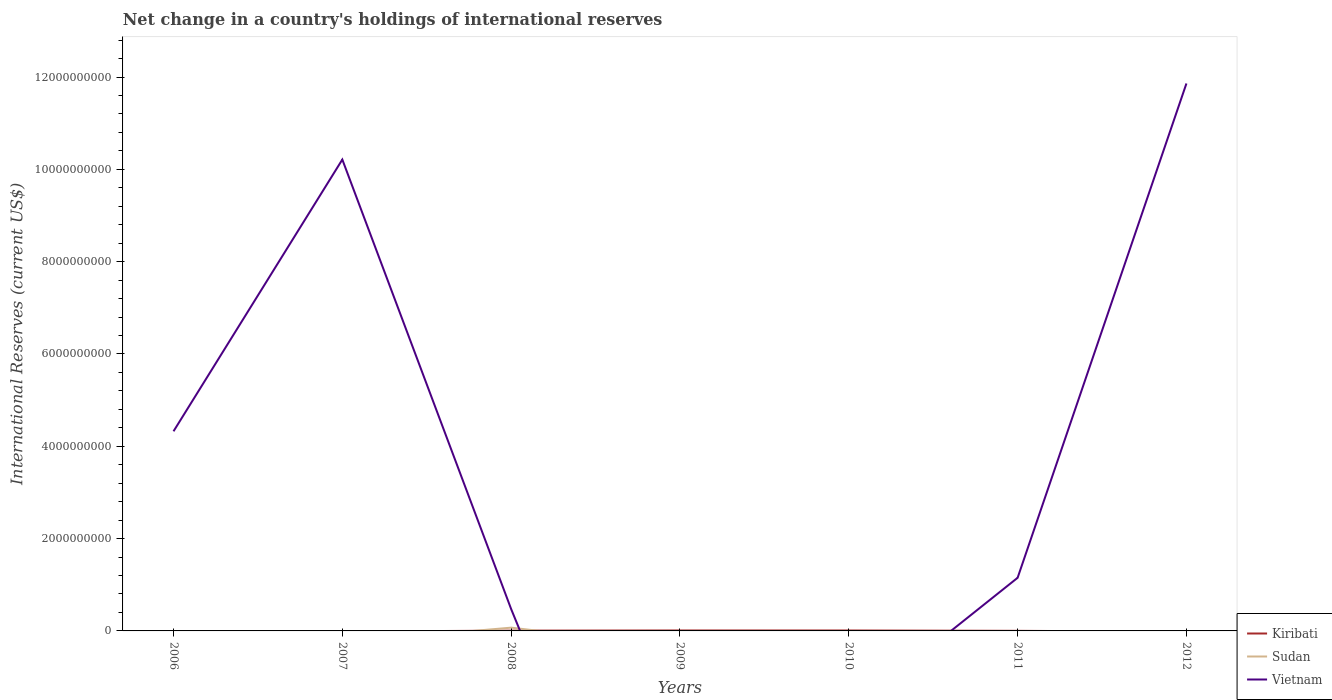Is the number of lines equal to the number of legend labels?
Offer a terse response. No. What is the total international reserves in Kiribati in the graph?
Offer a very short reply. 4.58e+06. What is the difference between the highest and the second highest international reserves in Sudan?
Offer a terse response. 7.08e+07. What is the difference between the highest and the lowest international reserves in Vietnam?
Offer a very short reply. 3. What is the difference between two consecutive major ticks on the Y-axis?
Offer a terse response. 2.00e+09. Are the values on the major ticks of Y-axis written in scientific E-notation?
Ensure brevity in your answer.  No. Does the graph contain any zero values?
Your answer should be very brief. Yes. Does the graph contain grids?
Your response must be concise. No. Where does the legend appear in the graph?
Provide a short and direct response. Bottom right. What is the title of the graph?
Provide a succinct answer. Net change in a country's holdings of international reserves. Does "Montenegro" appear as one of the legend labels in the graph?
Ensure brevity in your answer.  No. What is the label or title of the X-axis?
Your answer should be compact. Years. What is the label or title of the Y-axis?
Your answer should be very brief. International Reserves (current US$). What is the International Reserves (current US$) in Kiribati in 2006?
Ensure brevity in your answer.  0. What is the International Reserves (current US$) in Sudan in 2006?
Your answer should be very brief. 0. What is the International Reserves (current US$) in Vietnam in 2006?
Provide a short and direct response. 4.32e+09. What is the International Reserves (current US$) in Kiribati in 2007?
Provide a succinct answer. 0. What is the International Reserves (current US$) in Sudan in 2007?
Provide a succinct answer. 0. What is the International Reserves (current US$) of Vietnam in 2007?
Your answer should be very brief. 1.02e+1. What is the International Reserves (current US$) in Kiribati in 2008?
Ensure brevity in your answer.  6.53e+06. What is the International Reserves (current US$) of Sudan in 2008?
Offer a very short reply. 7.08e+07. What is the International Reserves (current US$) of Vietnam in 2008?
Offer a very short reply. 4.74e+08. What is the International Reserves (current US$) in Kiribati in 2009?
Your answer should be very brief. 9.89e+06. What is the International Reserves (current US$) in Sudan in 2009?
Offer a very short reply. 0. What is the International Reserves (current US$) in Kiribati in 2010?
Keep it short and to the point. 9.50e+06. What is the International Reserves (current US$) in Sudan in 2010?
Your response must be concise. 0. What is the International Reserves (current US$) in Vietnam in 2010?
Keep it short and to the point. 0. What is the International Reserves (current US$) of Kiribati in 2011?
Offer a terse response. 1.95e+06. What is the International Reserves (current US$) in Sudan in 2011?
Your answer should be compact. 0. What is the International Reserves (current US$) in Vietnam in 2011?
Make the answer very short. 1.15e+09. What is the International Reserves (current US$) of Kiribati in 2012?
Keep it short and to the point. 0. What is the International Reserves (current US$) of Vietnam in 2012?
Make the answer very short. 1.19e+1. Across all years, what is the maximum International Reserves (current US$) in Kiribati?
Provide a succinct answer. 9.89e+06. Across all years, what is the maximum International Reserves (current US$) of Sudan?
Offer a very short reply. 7.08e+07. Across all years, what is the maximum International Reserves (current US$) in Vietnam?
Provide a short and direct response. 1.19e+1. Across all years, what is the minimum International Reserves (current US$) of Sudan?
Ensure brevity in your answer.  0. Across all years, what is the minimum International Reserves (current US$) in Vietnam?
Ensure brevity in your answer.  0. What is the total International Reserves (current US$) of Kiribati in the graph?
Offer a very short reply. 2.79e+07. What is the total International Reserves (current US$) of Sudan in the graph?
Your answer should be compact. 7.08e+07. What is the total International Reserves (current US$) of Vietnam in the graph?
Provide a short and direct response. 2.80e+1. What is the difference between the International Reserves (current US$) in Vietnam in 2006 and that in 2007?
Provide a succinct answer. -5.89e+09. What is the difference between the International Reserves (current US$) in Vietnam in 2006 and that in 2008?
Provide a succinct answer. 3.85e+09. What is the difference between the International Reserves (current US$) of Vietnam in 2006 and that in 2011?
Make the answer very short. 3.17e+09. What is the difference between the International Reserves (current US$) of Vietnam in 2006 and that in 2012?
Ensure brevity in your answer.  -7.54e+09. What is the difference between the International Reserves (current US$) of Vietnam in 2007 and that in 2008?
Offer a very short reply. 9.74e+09. What is the difference between the International Reserves (current US$) in Vietnam in 2007 and that in 2011?
Your response must be concise. 9.06e+09. What is the difference between the International Reserves (current US$) of Vietnam in 2007 and that in 2012?
Offer a terse response. -1.65e+09. What is the difference between the International Reserves (current US$) in Kiribati in 2008 and that in 2009?
Your answer should be compact. -3.36e+06. What is the difference between the International Reserves (current US$) in Kiribati in 2008 and that in 2010?
Make the answer very short. -2.97e+06. What is the difference between the International Reserves (current US$) of Kiribati in 2008 and that in 2011?
Keep it short and to the point. 4.58e+06. What is the difference between the International Reserves (current US$) in Vietnam in 2008 and that in 2011?
Your answer should be very brief. -6.77e+08. What is the difference between the International Reserves (current US$) of Vietnam in 2008 and that in 2012?
Provide a short and direct response. -1.14e+1. What is the difference between the International Reserves (current US$) in Kiribati in 2009 and that in 2010?
Make the answer very short. 3.84e+05. What is the difference between the International Reserves (current US$) of Kiribati in 2009 and that in 2011?
Offer a very short reply. 7.94e+06. What is the difference between the International Reserves (current US$) of Kiribati in 2010 and that in 2011?
Provide a succinct answer. 7.55e+06. What is the difference between the International Reserves (current US$) in Vietnam in 2011 and that in 2012?
Your answer should be compact. -1.07e+1. What is the difference between the International Reserves (current US$) of Kiribati in 2008 and the International Reserves (current US$) of Vietnam in 2011?
Provide a short and direct response. -1.14e+09. What is the difference between the International Reserves (current US$) in Sudan in 2008 and the International Reserves (current US$) in Vietnam in 2011?
Your answer should be compact. -1.08e+09. What is the difference between the International Reserves (current US$) in Kiribati in 2008 and the International Reserves (current US$) in Vietnam in 2012?
Provide a short and direct response. -1.19e+1. What is the difference between the International Reserves (current US$) in Sudan in 2008 and the International Reserves (current US$) in Vietnam in 2012?
Give a very brief answer. -1.18e+1. What is the difference between the International Reserves (current US$) of Kiribati in 2009 and the International Reserves (current US$) of Vietnam in 2011?
Offer a very short reply. -1.14e+09. What is the difference between the International Reserves (current US$) in Kiribati in 2009 and the International Reserves (current US$) in Vietnam in 2012?
Your answer should be very brief. -1.18e+1. What is the difference between the International Reserves (current US$) of Kiribati in 2010 and the International Reserves (current US$) of Vietnam in 2011?
Make the answer very short. -1.14e+09. What is the difference between the International Reserves (current US$) in Kiribati in 2010 and the International Reserves (current US$) in Vietnam in 2012?
Keep it short and to the point. -1.19e+1. What is the difference between the International Reserves (current US$) in Kiribati in 2011 and the International Reserves (current US$) in Vietnam in 2012?
Keep it short and to the point. -1.19e+1. What is the average International Reserves (current US$) of Kiribati per year?
Your answer should be very brief. 3.98e+06. What is the average International Reserves (current US$) in Sudan per year?
Your answer should be compact. 1.01e+07. What is the average International Reserves (current US$) of Vietnam per year?
Your response must be concise. 4.00e+09. In the year 2008, what is the difference between the International Reserves (current US$) of Kiribati and International Reserves (current US$) of Sudan?
Keep it short and to the point. -6.43e+07. In the year 2008, what is the difference between the International Reserves (current US$) in Kiribati and International Reserves (current US$) in Vietnam?
Your answer should be very brief. -4.67e+08. In the year 2008, what is the difference between the International Reserves (current US$) in Sudan and International Reserves (current US$) in Vietnam?
Offer a very short reply. -4.03e+08. In the year 2011, what is the difference between the International Reserves (current US$) in Kiribati and International Reserves (current US$) in Vietnam?
Give a very brief answer. -1.15e+09. What is the ratio of the International Reserves (current US$) in Vietnam in 2006 to that in 2007?
Provide a succinct answer. 0.42. What is the ratio of the International Reserves (current US$) of Vietnam in 2006 to that in 2008?
Keep it short and to the point. 9.13. What is the ratio of the International Reserves (current US$) of Vietnam in 2006 to that in 2011?
Ensure brevity in your answer.  3.76. What is the ratio of the International Reserves (current US$) of Vietnam in 2006 to that in 2012?
Provide a short and direct response. 0.36. What is the ratio of the International Reserves (current US$) in Vietnam in 2007 to that in 2008?
Provide a succinct answer. 21.56. What is the ratio of the International Reserves (current US$) in Vietnam in 2007 to that in 2011?
Offer a terse response. 8.87. What is the ratio of the International Reserves (current US$) of Vietnam in 2007 to that in 2012?
Give a very brief answer. 0.86. What is the ratio of the International Reserves (current US$) of Kiribati in 2008 to that in 2009?
Give a very brief answer. 0.66. What is the ratio of the International Reserves (current US$) in Kiribati in 2008 to that in 2010?
Your answer should be compact. 0.69. What is the ratio of the International Reserves (current US$) of Kiribati in 2008 to that in 2011?
Offer a terse response. 3.35. What is the ratio of the International Reserves (current US$) in Vietnam in 2008 to that in 2011?
Your answer should be compact. 0.41. What is the ratio of the International Reserves (current US$) of Vietnam in 2008 to that in 2012?
Your answer should be compact. 0.04. What is the ratio of the International Reserves (current US$) of Kiribati in 2009 to that in 2010?
Your response must be concise. 1.04. What is the ratio of the International Reserves (current US$) of Kiribati in 2009 to that in 2011?
Your answer should be very brief. 5.07. What is the ratio of the International Reserves (current US$) in Kiribati in 2010 to that in 2011?
Offer a very short reply. 4.87. What is the ratio of the International Reserves (current US$) in Vietnam in 2011 to that in 2012?
Keep it short and to the point. 0.1. What is the difference between the highest and the second highest International Reserves (current US$) of Kiribati?
Provide a short and direct response. 3.84e+05. What is the difference between the highest and the second highest International Reserves (current US$) in Vietnam?
Your answer should be compact. 1.65e+09. What is the difference between the highest and the lowest International Reserves (current US$) of Kiribati?
Keep it short and to the point. 9.89e+06. What is the difference between the highest and the lowest International Reserves (current US$) of Sudan?
Provide a succinct answer. 7.08e+07. What is the difference between the highest and the lowest International Reserves (current US$) of Vietnam?
Provide a short and direct response. 1.19e+1. 